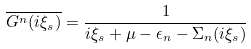<formula> <loc_0><loc_0><loc_500><loc_500>\overline { G ^ { n } ( i \xi _ { s } ) } = \frac { 1 } { i \xi _ { s } + \mu - \epsilon _ { n } - \Sigma _ { n } ( i \xi _ { s } ) }</formula> 